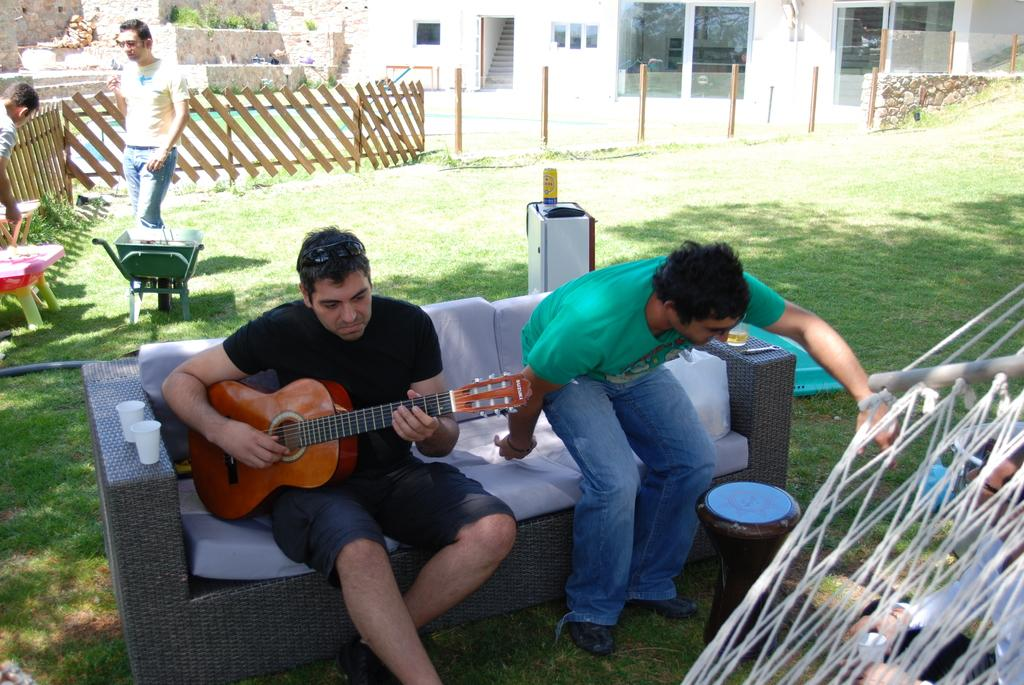How many people are in the image? There are five people in the image. Can you describe the clothing of one of the people? One person is wearing a black shirt. What is the person in the black shirt doing? The person in the black shirt is sitting and playing a guitar. What can be seen in the background of the image? There is a window, fencing, and trees in the background of the image. What type of card is being used to play the guitar in the image? There is no card present in the image, and the guitar is being played by a person, not a card. 